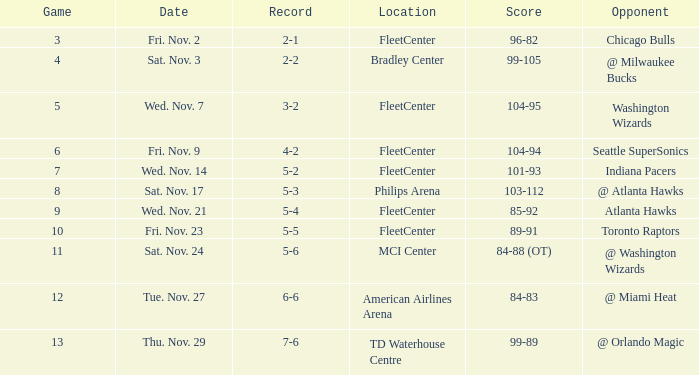Which opponent has a score of 84-88 (ot)? @ Washington Wizards. 